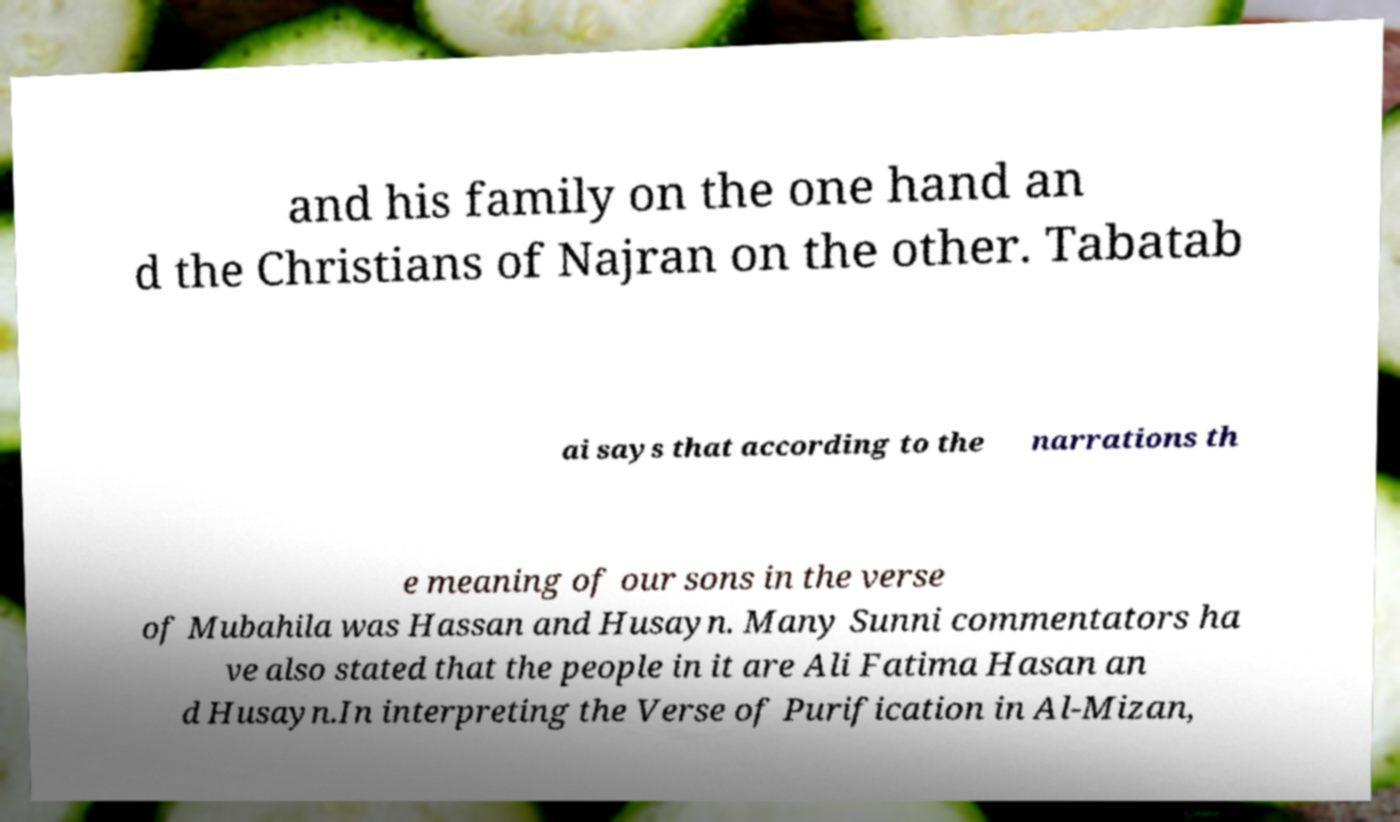Please read and relay the text visible in this image. What does it say? and his family on the one hand an d the Christians of Najran on the other. Tabatab ai says that according to the narrations th e meaning of our sons in the verse of Mubahila was Hassan and Husayn. Many Sunni commentators ha ve also stated that the people in it are Ali Fatima Hasan an d Husayn.In interpreting the Verse of Purification in Al-Mizan, 